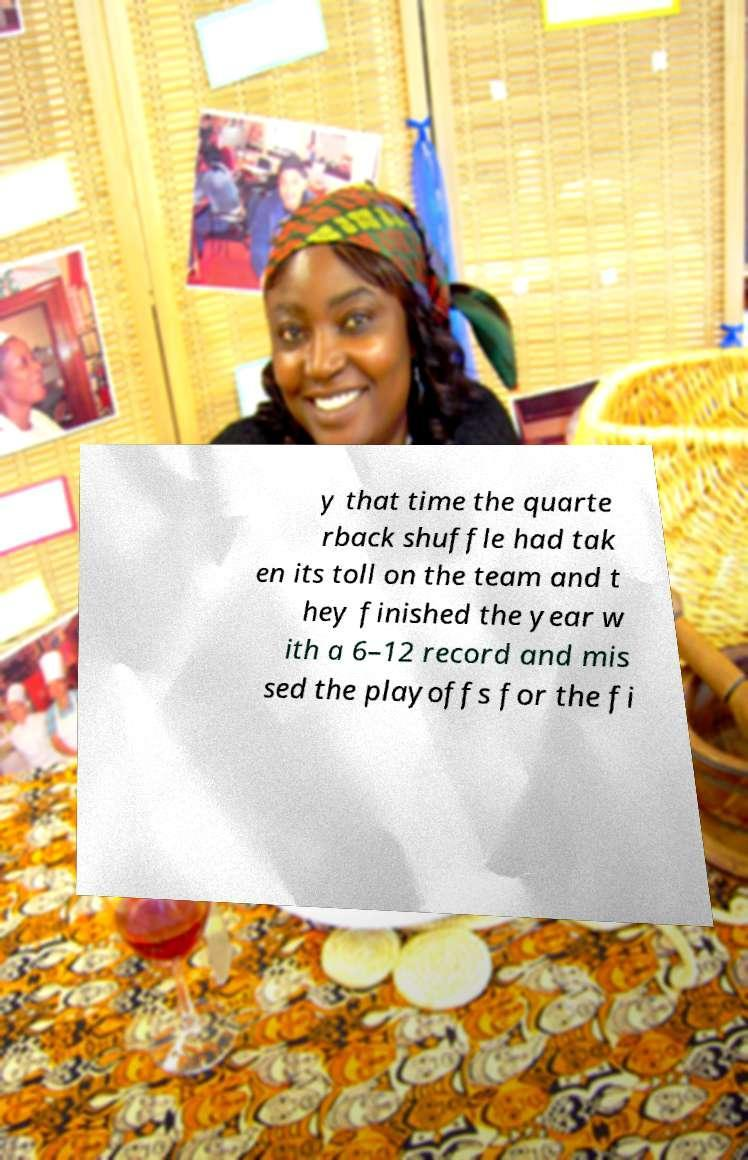What messages or text are displayed in this image? I need them in a readable, typed format. y that time the quarte rback shuffle had tak en its toll on the team and t hey finished the year w ith a 6–12 record and mis sed the playoffs for the fi 